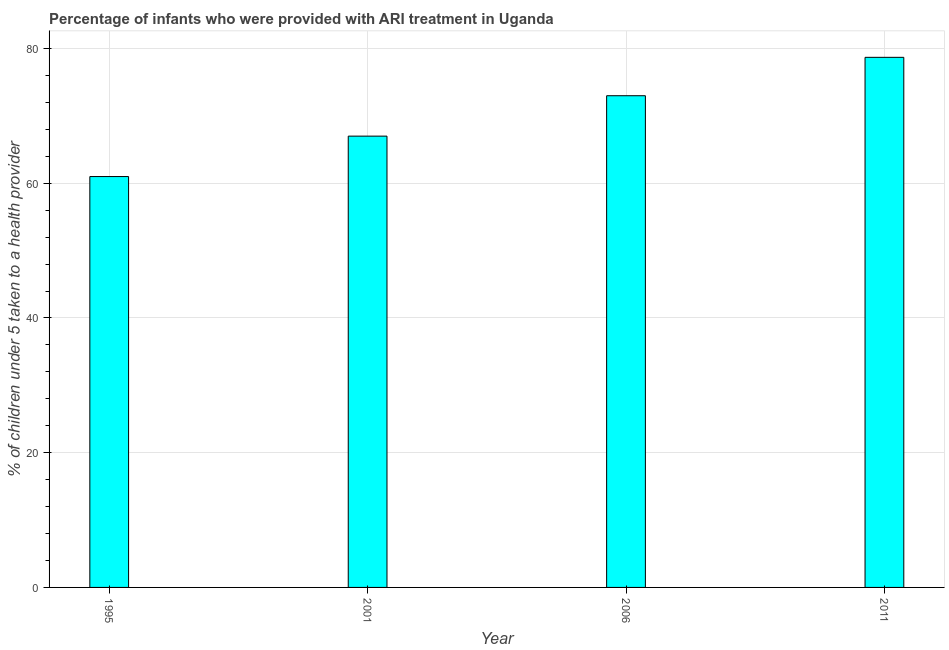Does the graph contain any zero values?
Your answer should be very brief. No. What is the title of the graph?
Offer a terse response. Percentage of infants who were provided with ARI treatment in Uganda. What is the label or title of the X-axis?
Make the answer very short. Year. What is the label or title of the Y-axis?
Offer a very short reply. % of children under 5 taken to a health provider. Across all years, what is the maximum percentage of children who were provided with ari treatment?
Offer a terse response. 78.7. Across all years, what is the minimum percentage of children who were provided with ari treatment?
Your answer should be compact. 61. What is the sum of the percentage of children who were provided with ari treatment?
Offer a very short reply. 279.7. What is the difference between the percentage of children who were provided with ari treatment in 1995 and 2011?
Ensure brevity in your answer.  -17.7. What is the average percentage of children who were provided with ari treatment per year?
Offer a terse response. 69.92. In how many years, is the percentage of children who were provided with ari treatment greater than 28 %?
Your answer should be very brief. 4. What is the ratio of the percentage of children who were provided with ari treatment in 2001 to that in 2006?
Your answer should be very brief. 0.92. In how many years, is the percentage of children who were provided with ari treatment greater than the average percentage of children who were provided with ari treatment taken over all years?
Offer a very short reply. 2. How many years are there in the graph?
Your answer should be compact. 4. What is the difference between two consecutive major ticks on the Y-axis?
Give a very brief answer. 20. Are the values on the major ticks of Y-axis written in scientific E-notation?
Your answer should be very brief. No. What is the % of children under 5 taken to a health provider in 2011?
Make the answer very short. 78.7. What is the difference between the % of children under 5 taken to a health provider in 1995 and 2006?
Offer a terse response. -12. What is the difference between the % of children under 5 taken to a health provider in 1995 and 2011?
Keep it short and to the point. -17.7. What is the difference between the % of children under 5 taken to a health provider in 2001 and 2011?
Your response must be concise. -11.7. What is the difference between the % of children under 5 taken to a health provider in 2006 and 2011?
Provide a succinct answer. -5.7. What is the ratio of the % of children under 5 taken to a health provider in 1995 to that in 2001?
Your response must be concise. 0.91. What is the ratio of the % of children under 5 taken to a health provider in 1995 to that in 2006?
Ensure brevity in your answer.  0.84. What is the ratio of the % of children under 5 taken to a health provider in 1995 to that in 2011?
Provide a succinct answer. 0.78. What is the ratio of the % of children under 5 taken to a health provider in 2001 to that in 2006?
Give a very brief answer. 0.92. What is the ratio of the % of children under 5 taken to a health provider in 2001 to that in 2011?
Your answer should be very brief. 0.85. What is the ratio of the % of children under 5 taken to a health provider in 2006 to that in 2011?
Make the answer very short. 0.93. 